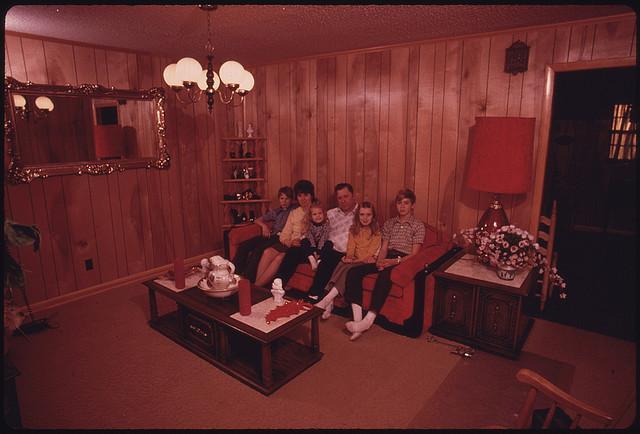How many people are on the couch?
Give a very brief answer. 6. How many trunks are near the man?
Give a very brief answer. 0. How many couches can you see?
Give a very brief answer. 1. How many people can be seen?
Give a very brief answer. 4. 